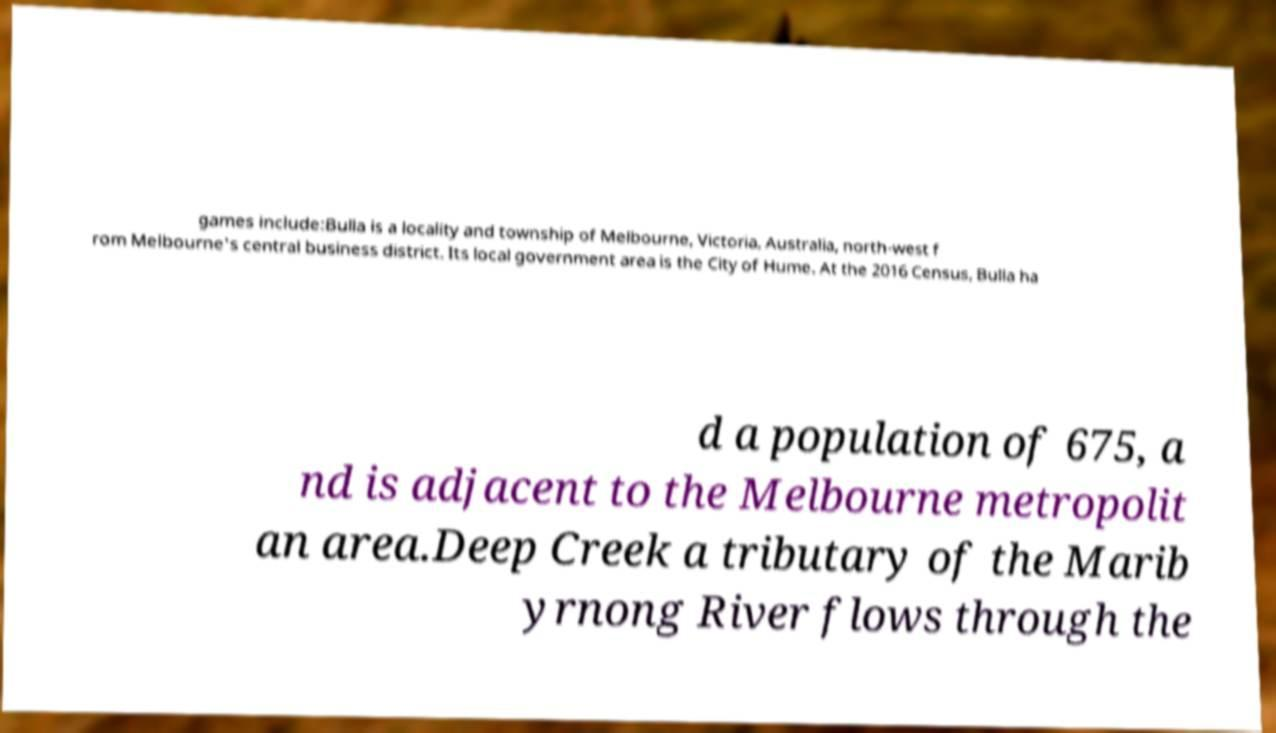Please read and relay the text visible in this image. What does it say? games include:Bulla is a locality and township of Melbourne, Victoria, Australia, north-west f rom Melbourne's central business district. Its local government area is the City of Hume. At the 2016 Census, Bulla ha d a population of 675, a nd is adjacent to the Melbourne metropolit an area.Deep Creek a tributary of the Marib yrnong River flows through the 